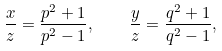<formula> <loc_0><loc_0><loc_500><loc_500>\frac { x } { z } = \frac { p ^ { 2 } + 1 } { p ^ { 2 } - 1 } , \quad \frac { y } { z } = \frac { q ^ { 2 } + 1 } { q ^ { 2 } - 1 } ,</formula> 